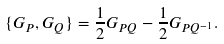Convert formula to latex. <formula><loc_0><loc_0><loc_500><loc_500>\{ G _ { P } , G _ { Q } \} = \frac { 1 } { 2 } G _ { P Q } - \frac { 1 } { 2 } G _ { P Q ^ { - 1 } } .</formula> 